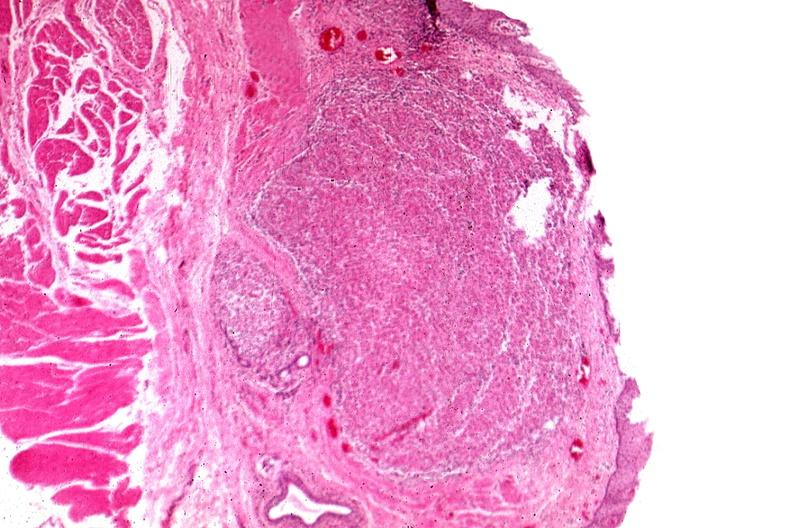s gastrointestinal present?
Answer the question using a single word or phrase. Yes 